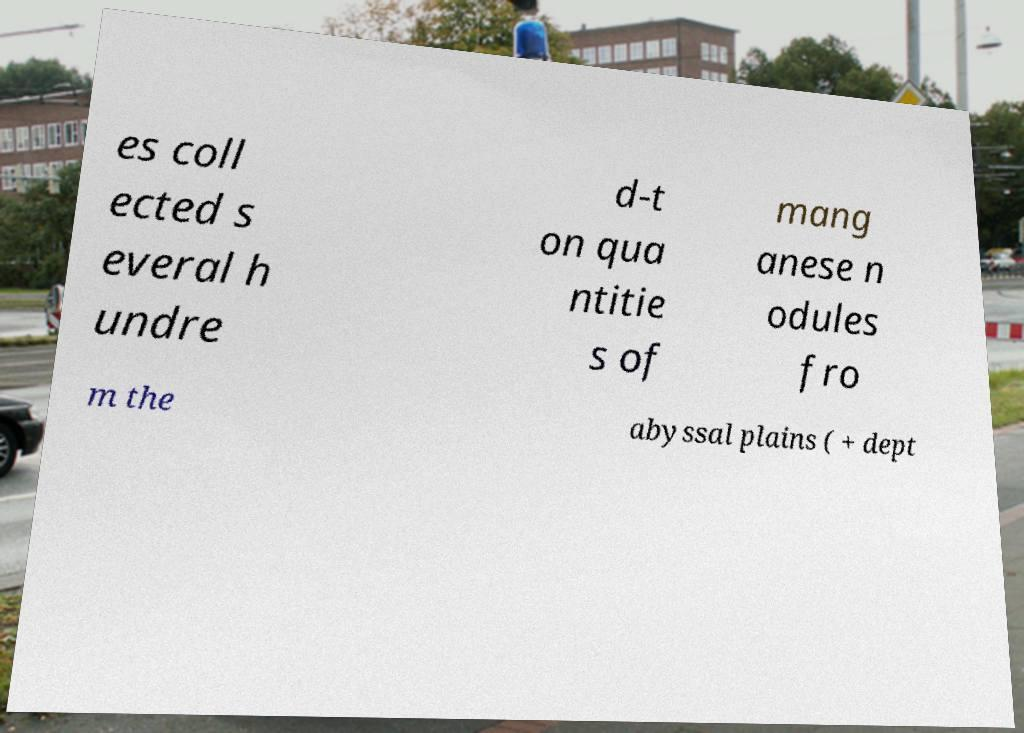There's text embedded in this image that I need extracted. Can you transcribe it verbatim? es coll ected s everal h undre d-t on qua ntitie s of mang anese n odules fro m the abyssal plains ( + dept 